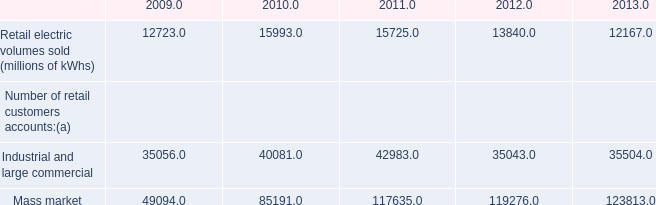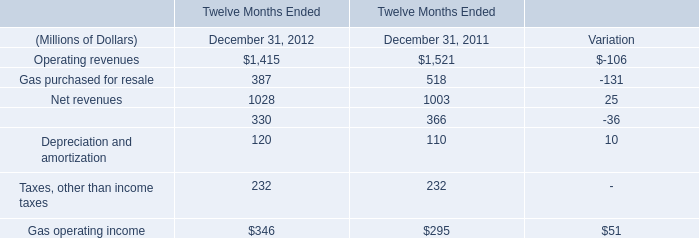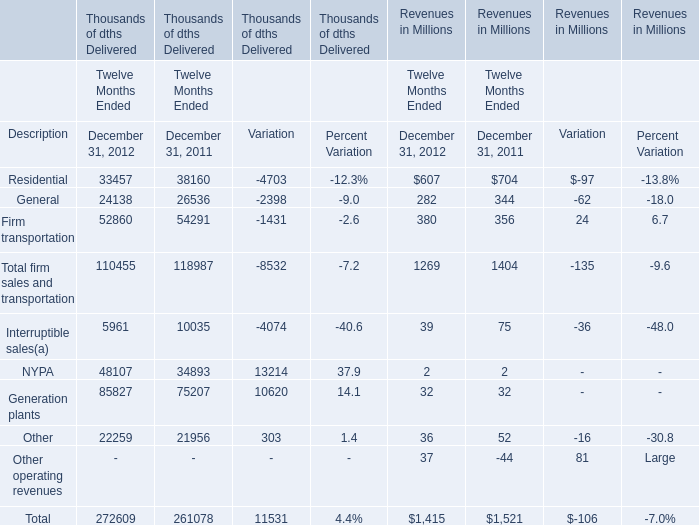What's the current growth rate of Firm transportation Revenues? 
Answer: 0.067. 